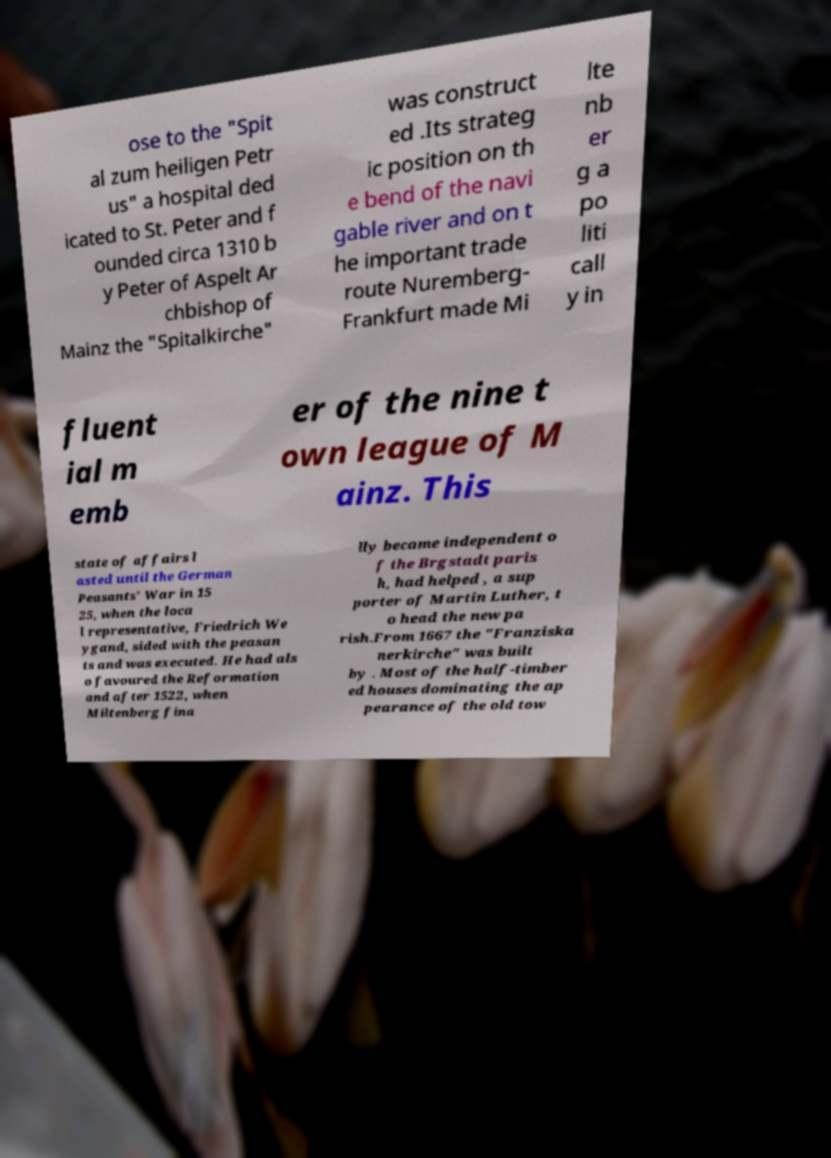Could you assist in decoding the text presented in this image and type it out clearly? ose to the "Spit al zum heiligen Petr us" a hospital ded icated to St. Peter and f ounded circa 1310 b y Peter of Aspelt Ar chbishop of Mainz the "Spitalkirche" was construct ed .Its strateg ic position on th e bend of the navi gable river and on t he important trade route Nuremberg- Frankfurt made Mi lte nb er g a po liti call y in fluent ial m emb er of the nine t own league of M ainz. This state of affairs l asted until the German Peasants' War in 15 25, when the loca l representative, Friedrich We ygand, sided with the peasan ts and was executed. He had als o favoured the Reformation and after 1522, when Miltenberg fina lly became independent o f the Brgstadt paris h, had helped , a sup porter of Martin Luther, t o head the new pa rish.From 1667 the "Franziska nerkirche" was built by . Most of the half-timber ed houses dominating the ap pearance of the old tow 